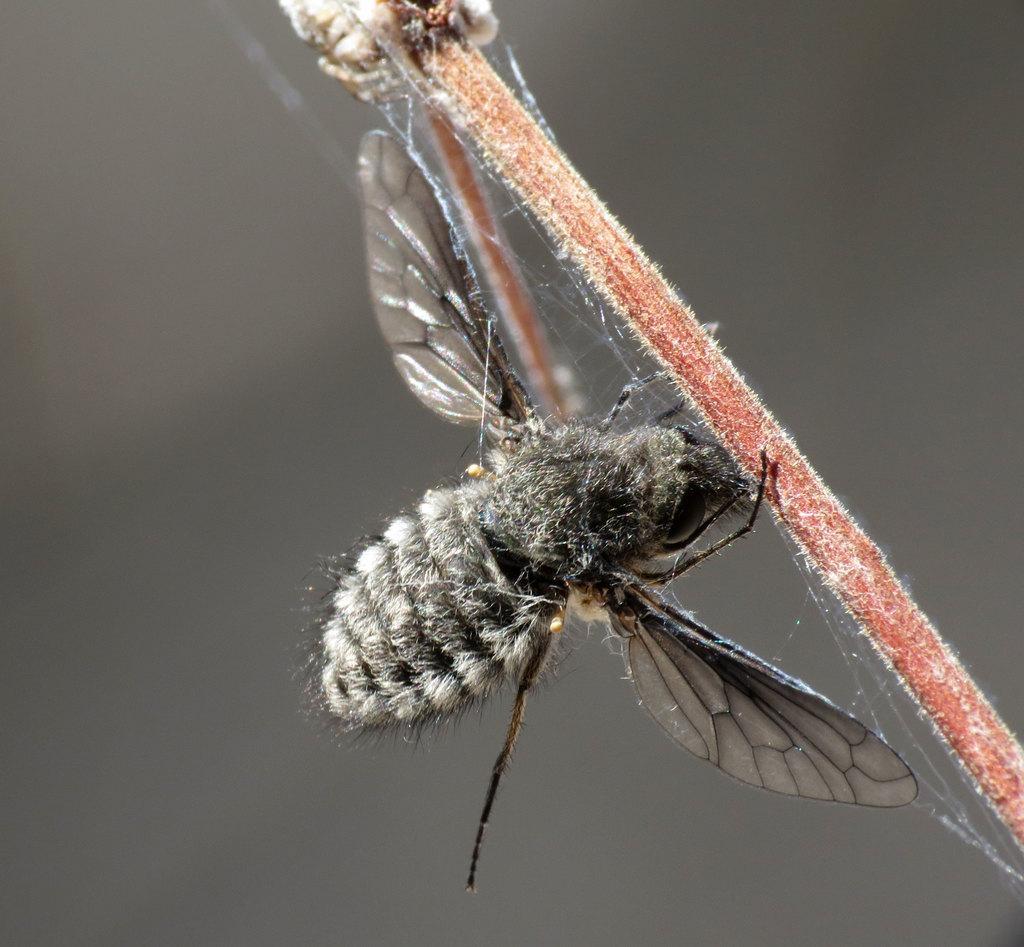How would you summarize this image in a sentence or two? In this image we can see an insect on the stem of a plant. 